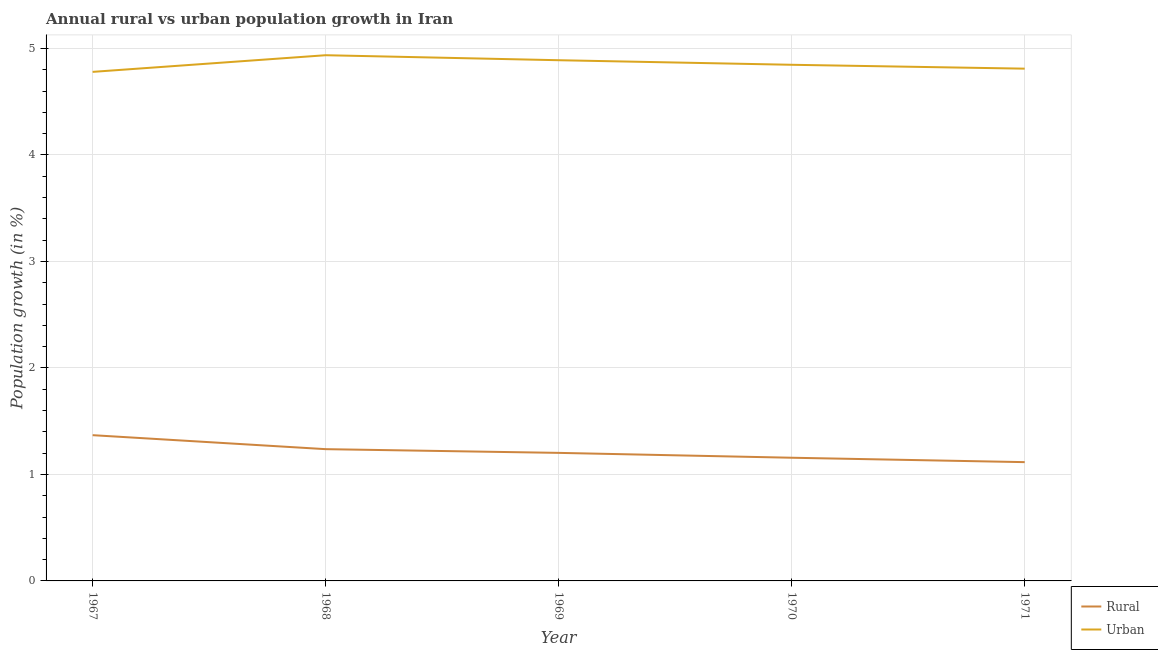What is the rural population growth in 1969?
Your answer should be very brief. 1.2. Across all years, what is the maximum urban population growth?
Keep it short and to the point. 4.94. Across all years, what is the minimum urban population growth?
Make the answer very short. 4.78. In which year was the rural population growth maximum?
Your answer should be very brief. 1967. What is the total urban population growth in the graph?
Ensure brevity in your answer.  24.26. What is the difference between the rural population growth in 1969 and that in 1971?
Offer a very short reply. 0.09. What is the difference between the rural population growth in 1971 and the urban population growth in 1967?
Your answer should be compact. -3.66. What is the average urban population growth per year?
Ensure brevity in your answer.  4.85. In the year 1968, what is the difference between the rural population growth and urban population growth?
Your answer should be compact. -3.7. What is the ratio of the urban population growth in 1968 to that in 1970?
Offer a very short reply. 1.02. Is the urban population growth in 1969 less than that in 1970?
Provide a short and direct response. No. What is the difference between the highest and the second highest urban population growth?
Your response must be concise. 0.05. What is the difference between the highest and the lowest urban population growth?
Provide a short and direct response. 0.16. In how many years, is the urban population growth greater than the average urban population growth taken over all years?
Offer a very short reply. 2. Is the sum of the rural population growth in 1967 and 1969 greater than the maximum urban population growth across all years?
Provide a short and direct response. No. Is the rural population growth strictly greater than the urban population growth over the years?
Your answer should be compact. No. Is the urban population growth strictly less than the rural population growth over the years?
Your response must be concise. No. How many lines are there?
Your answer should be very brief. 2. How many years are there in the graph?
Your response must be concise. 5. Are the values on the major ticks of Y-axis written in scientific E-notation?
Keep it short and to the point. No. Does the graph contain grids?
Give a very brief answer. Yes. Where does the legend appear in the graph?
Provide a succinct answer. Bottom right. How are the legend labels stacked?
Your answer should be compact. Vertical. What is the title of the graph?
Make the answer very short. Annual rural vs urban population growth in Iran. What is the label or title of the X-axis?
Ensure brevity in your answer.  Year. What is the label or title of the Y-axis?
Ensure brevity in your answer.  Population growth (in %). What is the Population growth (in %) in Rural in 1967?
Your answer should be compact. 1.37. What is the Population growth (in %) of Urban  in 1967?
Make the answer very short. 4.78. What is the Population growth (in %) of Rural in 1968?
Offer a terse response. 1.24. What is the Population growth (in %) of Urban  in 1968?
Give a very brief answer. 4.94. What is the Population growth (in %) of Rural in 1969?
Your answer should be very brief. 1.2. What is the Population growth (in %) in Urban  in 1969?
Ensure brevity in your answer.  4.89. What is the Population growth (in %) of Rural in 1970?
Provide a short and direct response. 1.16. What is the Population growth (in %) of Urban  in 1970?
Ensure brevity in your answer.  4.85. What is the Population growth (in %) in Rural in 1971?
Make the answer very short. 1.12. What is the Population growth (in %) in Urban  in 1971?
Provide a succinct answer. 4.81. Across all years, what is the maximum Population growth (in %) in Rural?
Offer a very short reply. 1.37. Across all years, what is the maximum Population growth (in %) of Urban ?
Ensure brevity in your answer.  4.94. Across all years, what is the minimum Population growth (in %) in Rural?
Offer a very short reply. 1.12. Across all years, what is the minimum Population growth (in %) in Urban ?
Keep it short and to the point. 4.78. What is the total Population growth (in %) in Rural in the graph?
Offer a terse response. 6.08. What is the total Population growth (in %) in Urban  in the graph?
Make the answer very short. 24.26. What is the difference between the Population growth (in %) of Rural in 1967 and that in 1968?
Provide a succinct answer. 0.13. What is the difference between the Population growth (in %) of Urban  in 1967 and that in 1968?
Your response must be concise. -0.16. What is the difference between the Population growth (in %) in Rural in 1967 and that in 1969?
Your answer should be compact. 0.17. What is the difference between the Population growth (in %) of Urban  in 1967 and that in 1969?
Keep it short and to the point. -0.11. What is the difference between the Population growth (in %) in Rural in 1967 and that in 1970?
Your response must be concise. 0.21. What is the difference between the Population growth (in %) in Urban  in 1967 and that in 1970?
Keep it short and to the point. -0.07. What is the difference between the Population growth (in %) of Rural in 1967 and that in 1971?
Offer a terse response. 0.25. What is the difference between the Population growth (in %) in Urban  in 1967 and that in 1971?
Give a very brief answer. -0.03. What is the difference between the Population growth (in %) in Rural in 1968 and that in 1969?
Give a very brief answer. 0.03. What is the difference between the Population growth (in %) of Urban  in 1968 and that in 1969?
Make the answer very short. 0.05. What is the difference between the Population growth (in %) in Rural in 1968 and that in 1970?
Provide a succinct answer. 0.08. What is the difference between the Population growth (in %) in Urban  in 1968 and that in 1970?
Keep it short and to the point. 0.09. What is the difference between the Population growth (in %) in Rural in 1968 and that in 1971?
Offer a terse response. 0.12. What is the difference between the Population growth (in %) of Urban  in 1968 and that in 1971?
Give a very brief answer. 0.13. What is the difference between the Population growth (in %) in Rural in 1969 and that in 1970?
Offer a terse response. 0.05. What is the difference between the Population growth (in %) in Urban  in 1969 and that in 1970?
Give a very brief answer. 0.04. What is the difference between the Population growth (in %) in Rural in 1969 and that in 1971?
Offer a terse response. 0.09. What is the difference between the Population growth (in %) in Urban  in 1969 and that in 1971?
Offer a very short reply. 0.08. What is the difference between the Population growth (in %) in Rural in 1970 and that in 1971?
Provide a short and direct response. 0.04. What is the difference between the Population growth (in %) of Urban  in 1970 and that in 1971?
Make the answer very short. 0.04. What is the difference between the Population growth (in %) in Rural in 1967 and the Population growth (in %) in Urban  in 1968?
Make the answer very short. -3.57. What is the difference between the Population growth (in %) in Rural in 1967 and the Population growth (in %) in Urban  in 1969?
Your answer should be very brief. -3.52. What is the difference between the Population growth (in %) of Rural in 1967 and the Population growth (in %) of Urban  in 1970?
Keep it short and to the point. -3.48. What is the difference between the Population growth (in %) in Rural in 1967 and the Population growth (in %) in Urban  in 1971?
Offer a terse response. -3.44. What is the difference between the Population growth (in %) of Rural in 1968 and the Population growth (in %) of Urban  in 1969?
Give a very brief answer. -3.65. What is the difference between the Population growth (in %) in Rural in 1968 and the Population growth (in %) in Urban  in 1970?
Give a very brief answer. -3.61. What is the difference between the Population growth (in %) of Rural in 1968 and the Population growth (in %) of Urban  in 1971?
Your answer should be compact. -3.57. What is the difference between the Population growth (in %) in Rural in 1969 and the Population growth (in %) in Urban  in 1970?
Ensure brevity in your answer.  -3.64. What is the difference between the Population growth (in %) in Rural in 1969 and the Population growth (in %) in Urban  in 1971?
Keep it short and to the point. -3.61. What is the difference between the Population growth (in %) in Rural in 1970 and the Population growth (in %) in Urban  in 1971?
Offer a terse response. -3.65. What is the average Population growth (in %) in Rural per year?
Make the answer very short. 1.22. What is the average Population growth (in %) of Urban  per year?
Offer a very short reply. 4.85. In the year 1967, what is the difference between the Population growth (in %) of Rural and Population growth (in %) of Urban ?
Keep it short and to the point. -3.41. In the year 1968, what is the difference between the Population growth (in %) of Rural and Population growth (in %) of Urban ?
Keep it short and to the point. -3.7. In the year 1969, what is the difference between the Population growth (in %) of Rural and Population growth (in %) of Urban ?
Your response must be concise. -3.69. In the year 1970, what is the difference between the Population growth (in %) in Rural and Population growth (in %) in Urban ?
Give a very brief answer. -3.69. In the year 1971, what is the difference between the Population growth (in %) in Rural and Population growth (in %) in Urban ?
Provide a succinct answer. -3.69. What is the ratio of the Population growth (in %) in Rural in 1967 to that in 1968?
Provide a short and direct response. 1.11. What is the ratio of the Population growth (in %) in Urban  in 1967 to that in 1968?
Keep it short and to the point. 0.97. What is the ratio of the Population growth (in %) of Rural in 1967 to that in 1969?
Provide a short and direct response. 1.14. What is the ratio of the Population growth (in %) of Urban  in 1967 to that in 1969?
Your response must be concise. 0.98. What is the ratio of the Population growth (in %) in Rural in 1967 to that in 1970?
Ensure brevity in your answer.  1.18. What is the ratio of the Population growth (in %) in Urban  in 1967 to that in 1970?
Ensure brevity in your answer.  0.99. What is the ratio of the Population growth (in %) in Rural in 1967 to that in 1971?
Offer a terse response. 1.23. What is the ratio of the Population growth (in %) in Urban  in 1968 to that in 1969?
Give a very brief answer. 1.01. What is the ratio of the Population growth (in %) of Rural in 1968 to that in 1970?
Provide a short and direct response. 1.07. What is the ratio of the Population growth (in %) of Urban  in 1968 to that in 1970?
Ensure brevity in your answer.  1.02. What is the ratio of the Population growth (in %) of Rural in 1968 to that in 1971?
Keep it short and to the point. 1.11. What is the ratio of the Population growth (in %) of Urban  in 1968 to that in 1971?
Make the answer very short. 1.03. What is the ratio of the Population growth (in %) in Rural in 1969 to that in 1970?
Provide a short and direct response. 1.04. What is the ratio of the Population growth (in %) in Urban  in 1969 to that in 1970?
Ensure brevity in your answer.  1.01. What is the ratio of the Population growth (in %) of Rural in 1969 to that in 1971?
Your answer should be compact. 1.08. What is the ratio of the Population growth (in %) in Urban  in 1969 to that in 1971?
Your response must be concise. 1.02. What is the ratio of the Population growth (in %) of Rural in 1970 to that in 1971?
Ensure brevity in your answer.  1.04. What is the ratio of the Population growth (in %) of Urban  in 1970 to that in 1971?
Your answer should be very brief. 1.01. What is the difference between the highest and the second highest Population growth (in %) of Rural?
Keep it short and to the point. 0.13. What is the difference between the highest and the second highest Population growth (in %) of Urban ?
Make the answer very short. 0.05. What is the difference between the highest and the lowest Population growth (in %) in Rural?
Ensure brevity in your answer.  0.25. What is the difference between the highest and the lowest Population growth (in %) of Urban ?
Give a very brief answer. 0.16. 